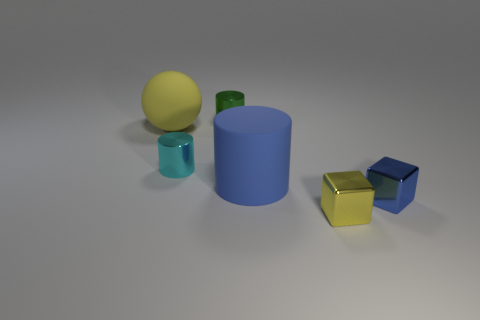Subtract all yellow cubes. How many cubes are left? 1 Subtract all shiny cylinders. How many cylinders are left? 1 Add 1 blue cylinders. How many objects exist? 7 Subtract 0 red cylinders. How many objects are left? 6 Subtract all blocks. How many objects are left? 4 Subtract 1 cylinders. How many cylinders are left? 2 Subtract all blue blocks. Subtract all blue cylinders. How many blocks are left? 1 Subtract all red blocks. How many cyan cylinders are left? 1 Subtract all small shiny cubes. Subtract all small brown metal spheres. How many objects are left? 4 Add 3 big yellow objects. How many big yellow objects are left? 4 